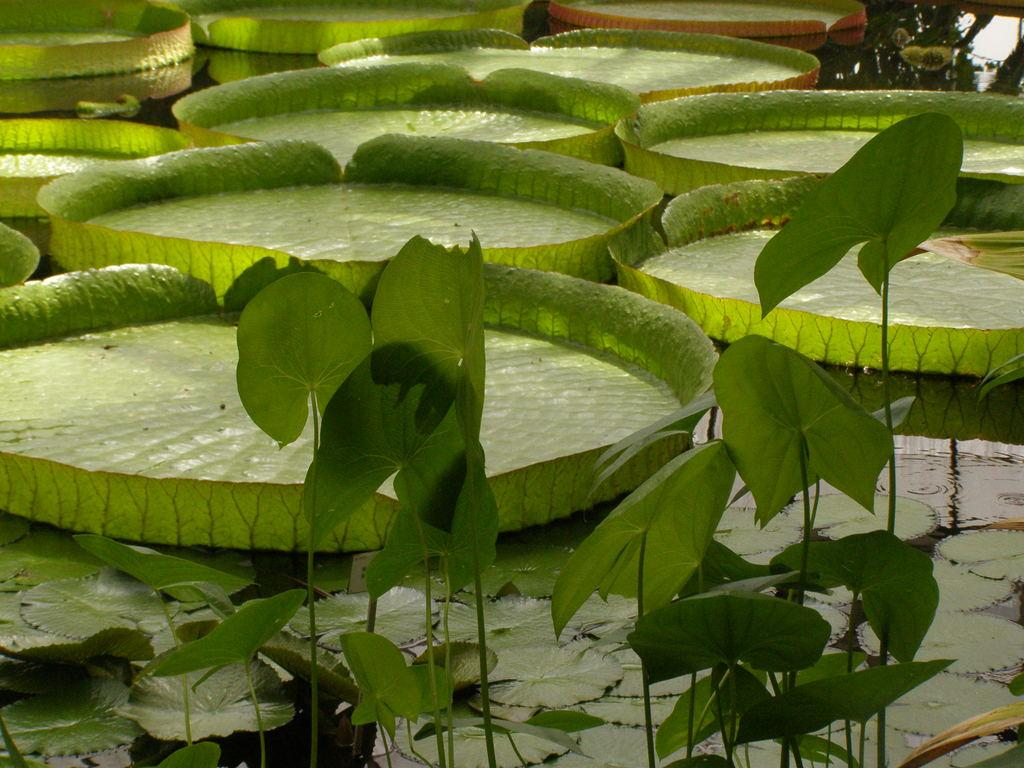What type of living organisms can be seen in the image? Plants can be seen in the image. What part of the plants are visible in the image? The plants have leaves that are visible in the image. What type of event is taking place at the harbor in the image? There is no harbor or event present in the image; it only features plants with leaves. 